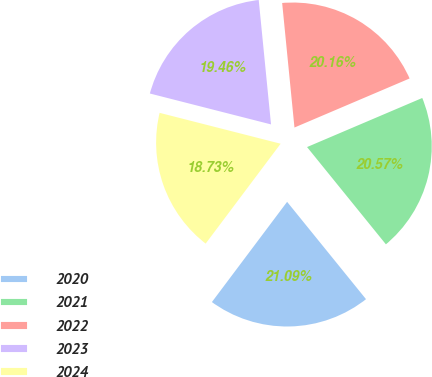Convert chart. <chart><loc_0><loc_0><loc_500><loc_500><pie_chart><fcel>2020<fcel>2021<fcel>2022<fcel>2023<fcel>2024<nl><fcel>21.09%<fcel>20.57%<fcel>20.16%<fcel>19.46%<fcel>18.73%<nl></chart> 